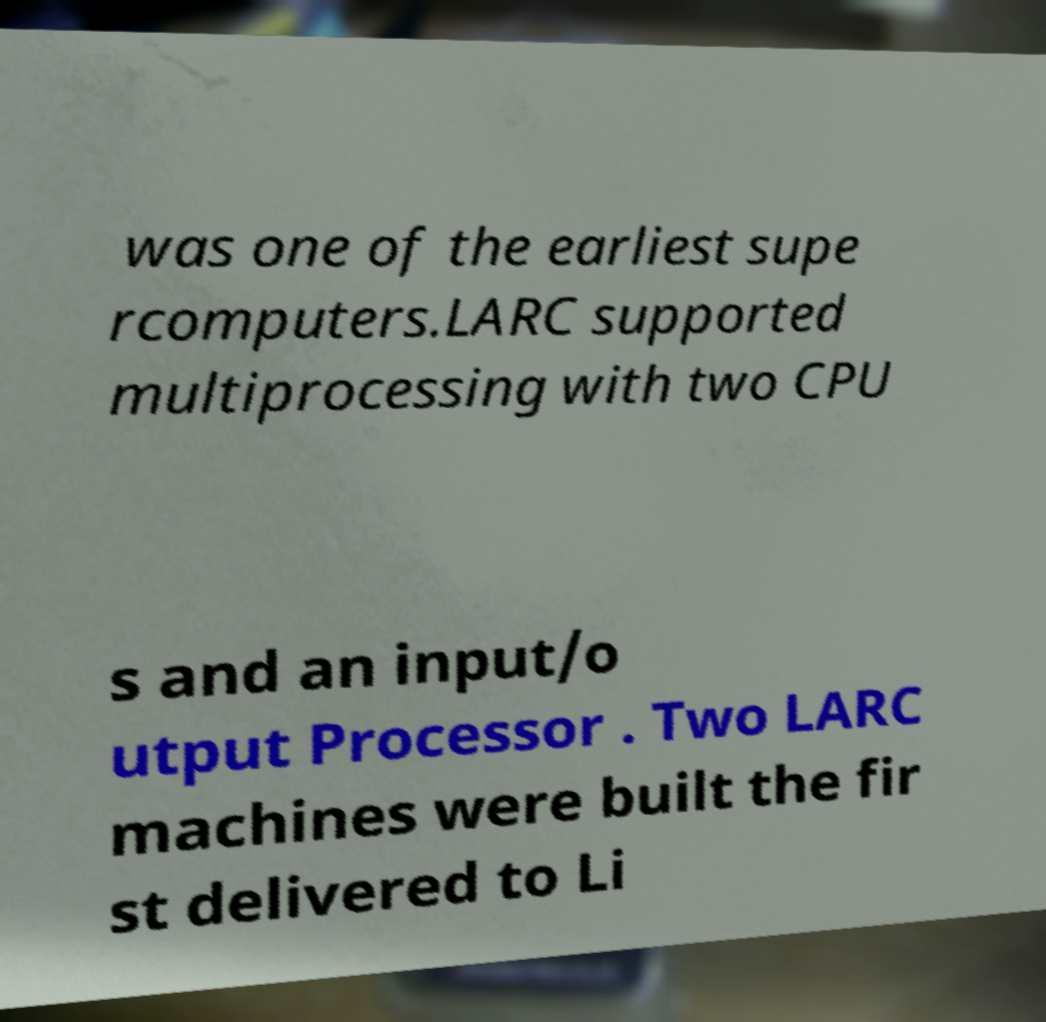Can you accurately transcribe the text from the provided image for me? was one of the earliest supe rcomputers.LARC supported multiprocessing with two CPU s and an input/o utput Processor . Two LARC machines were built the fir st delivered to Li 